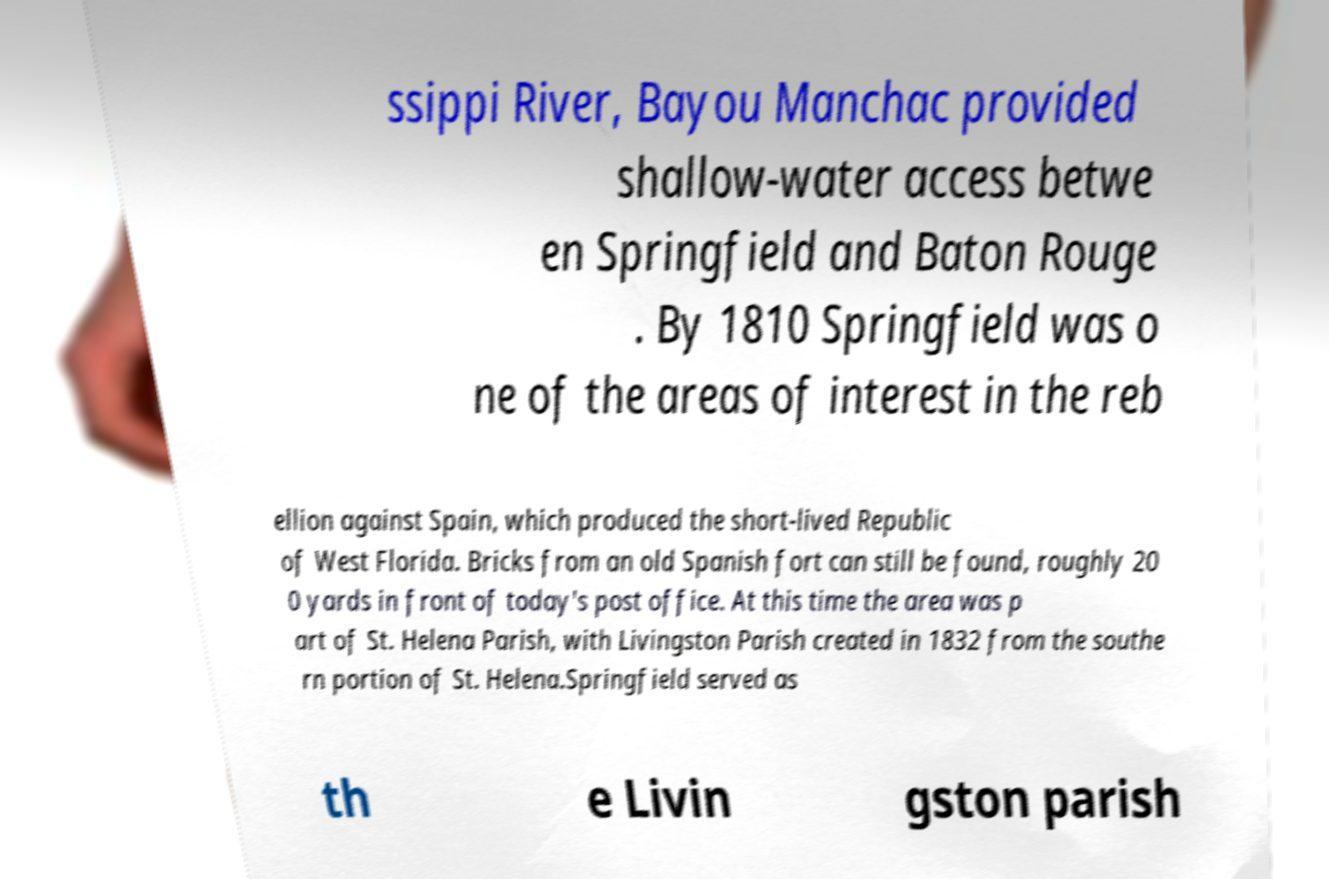For documentation purposes, I need the text within this image transcribed. Could you provide that? ssippi River, Bayou Manchac provided shallow-water access betwe en Springfield and Baton Rouge . By 1810 Springfield was o ne of the areas of interest in the reb ellion against Spain, which produced the short-lived Republic of West Florida. Bricks from an old Spanish fort can still be found, roughly 20 0 yards in front of today's post office. At this time the area was p art of St. Helena Parish, with Livingston Parish created in 1832 from the southe rn portion of St. Helena.Springfield served as th e Livin gston parish 